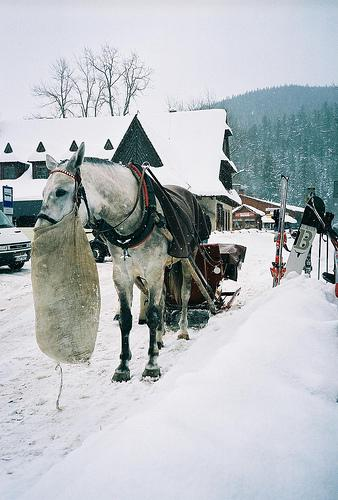Question: who is pictured?
Choices:
A. A horse.
B. An old lady.
C. An elephant.
D. A monkey.
Answer with the letter. Answer: A Question: what is he doing?
Choices:
A. Laughing.
B. Cleaning.
C. Working.
D. Eating.
Answer with the letter. Answer: D Question: where is this picture taken?
Choices:
A. Outside in the snow.
B. In the mountains.
C. At a stadium.
D. At the zoo.
Answer with the letter. Answer: A Question: when was the photo taken?
Choices:
A. Daylight.
B. Night time.
C. Thanksgiving.
D. Halloween.
Answer with the letter. Answer: A 